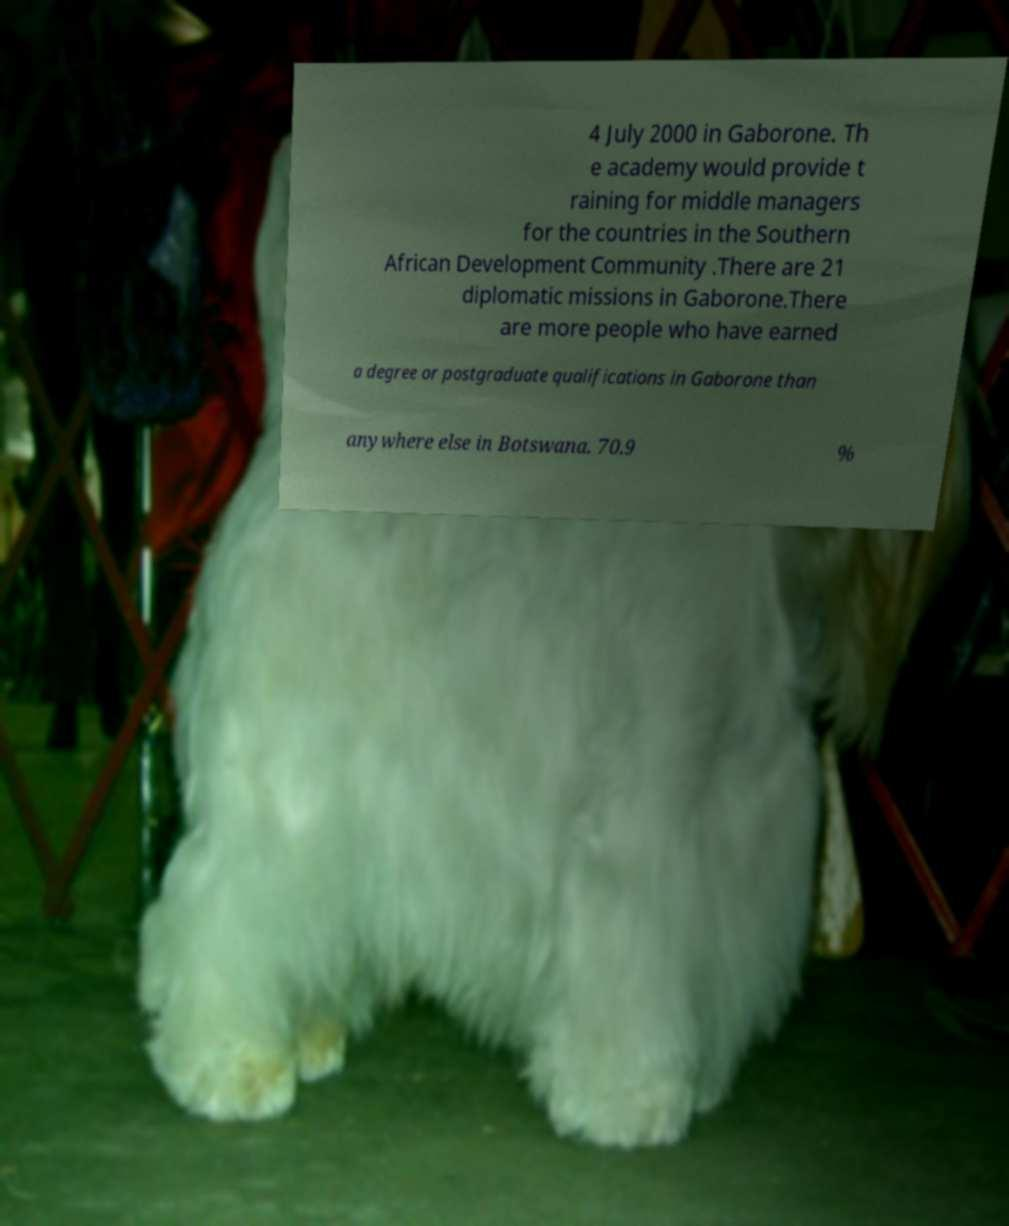Please identify and transcribe the text found in this image. 4 July 2000 in Gaborone. Th e academy would provide t raining for middle managers for the countries in the Southern African Development Community .There are 21 diplomatic missions in Gaborone.There are more people who have earned a degree or postgraduate qualifications in Gaborone than anywhere else in Botswana. 70.9 % 